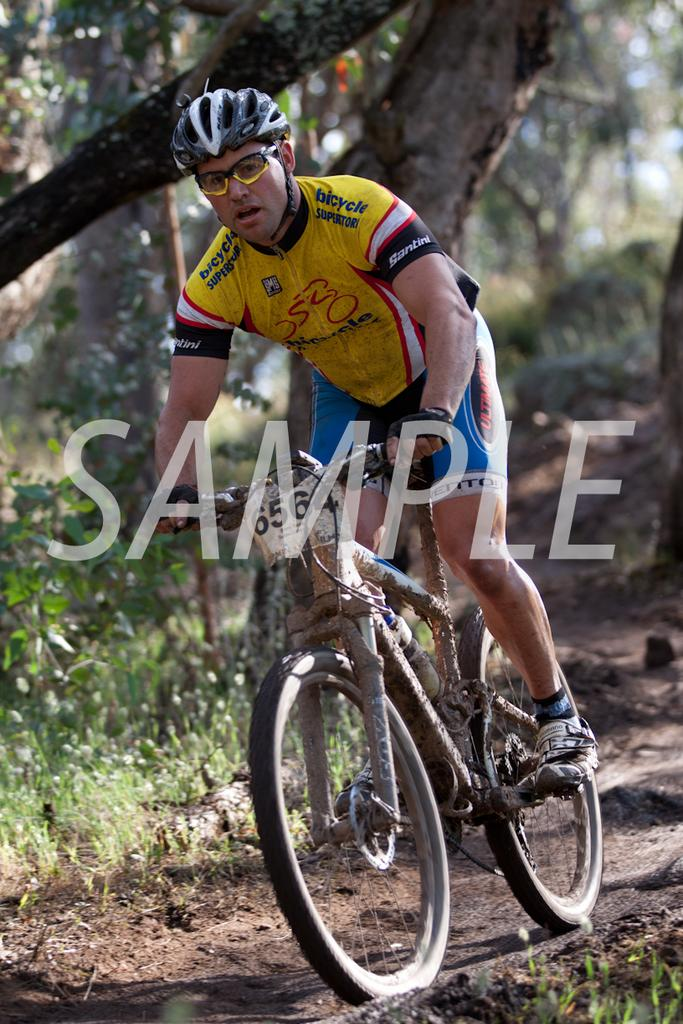What is the man in the image doing? The man is riding a bicycle in the image. What accessories is the man wearing while riding the bicycle? The man is wearing spectacles and a helmet. What can be seen in the background of the image? There are trees and plants in the background of the image. How many rabbits are hopping alongside the man in the image? There are no rabbits present in the image; the man is riding a bicycle with no animals accompanying him. What is the cause of the man's decision to wear a helmet while riding the bicycle? The image does not provide information about the man's reasons for wearing a helmet, so we cannot determine the cause. 